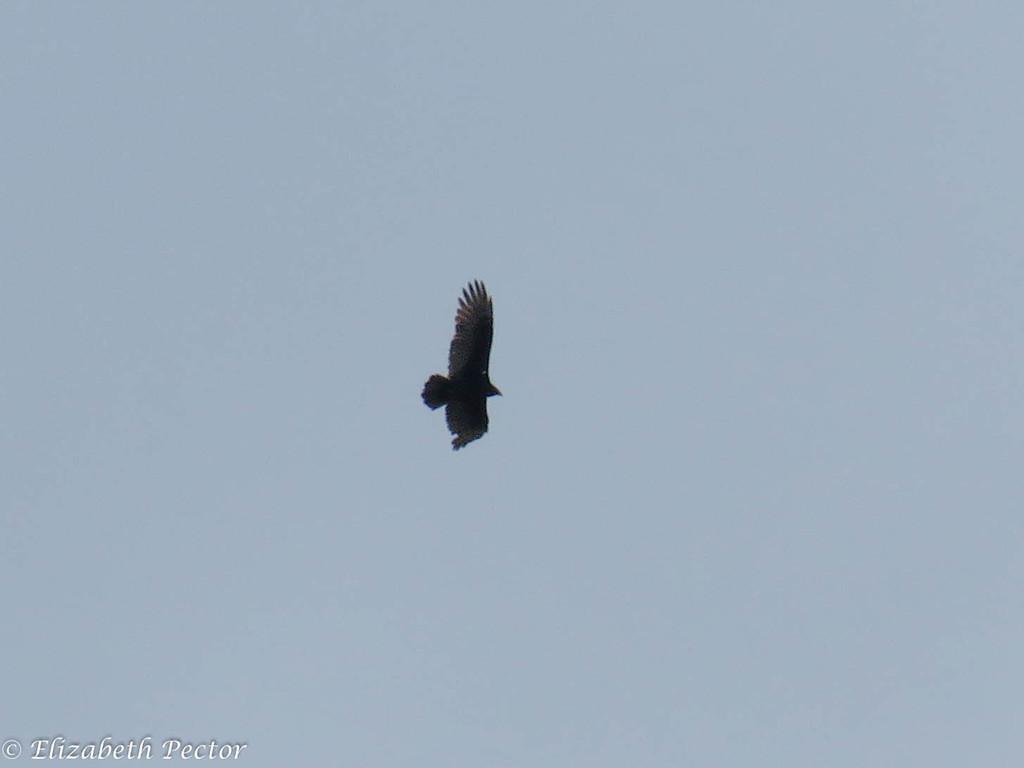Can you describe this image briefly? In this image I can see a black colour bird in air. In the background I can see the sky and in the left bottom side I can see a watermark. 